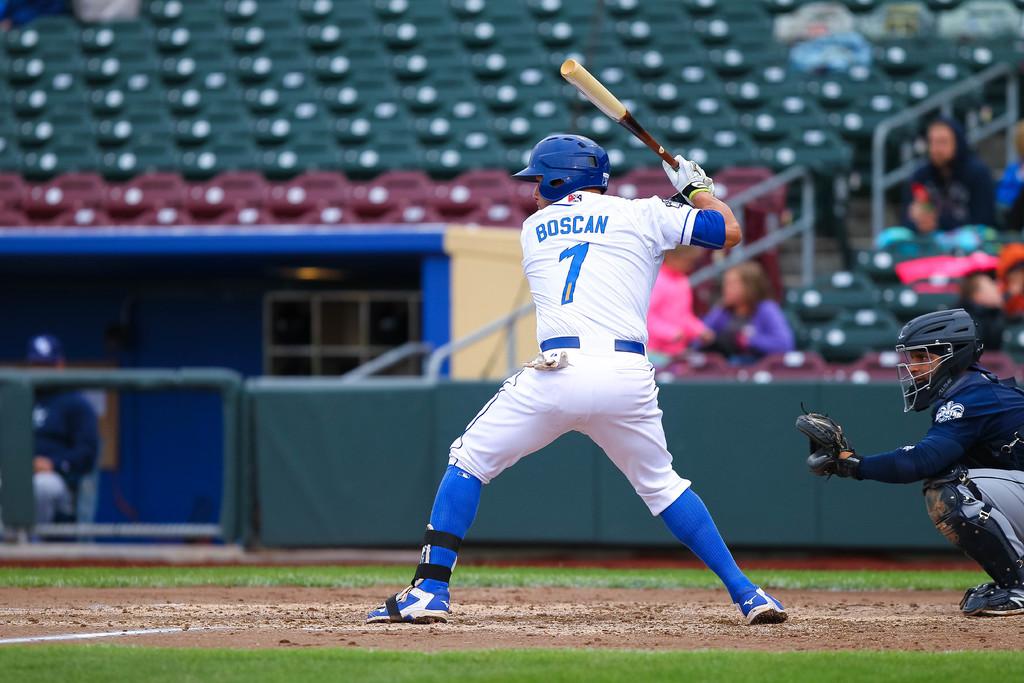What number is on the jersey?
Keep it short and to the point. 7. 